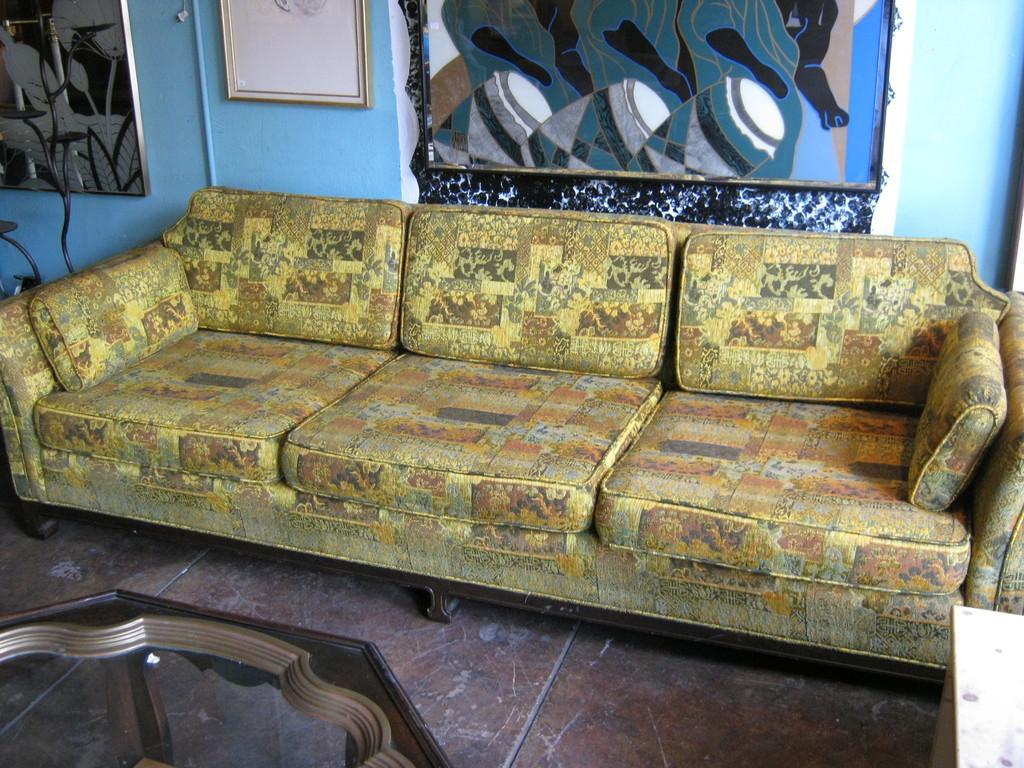Describe this image in one or two sentences. In this image I can see the floor, a table and a couch which is yellow, brown, black and orange in color. I can see the blue colored wall and few frames attached to the wall. 